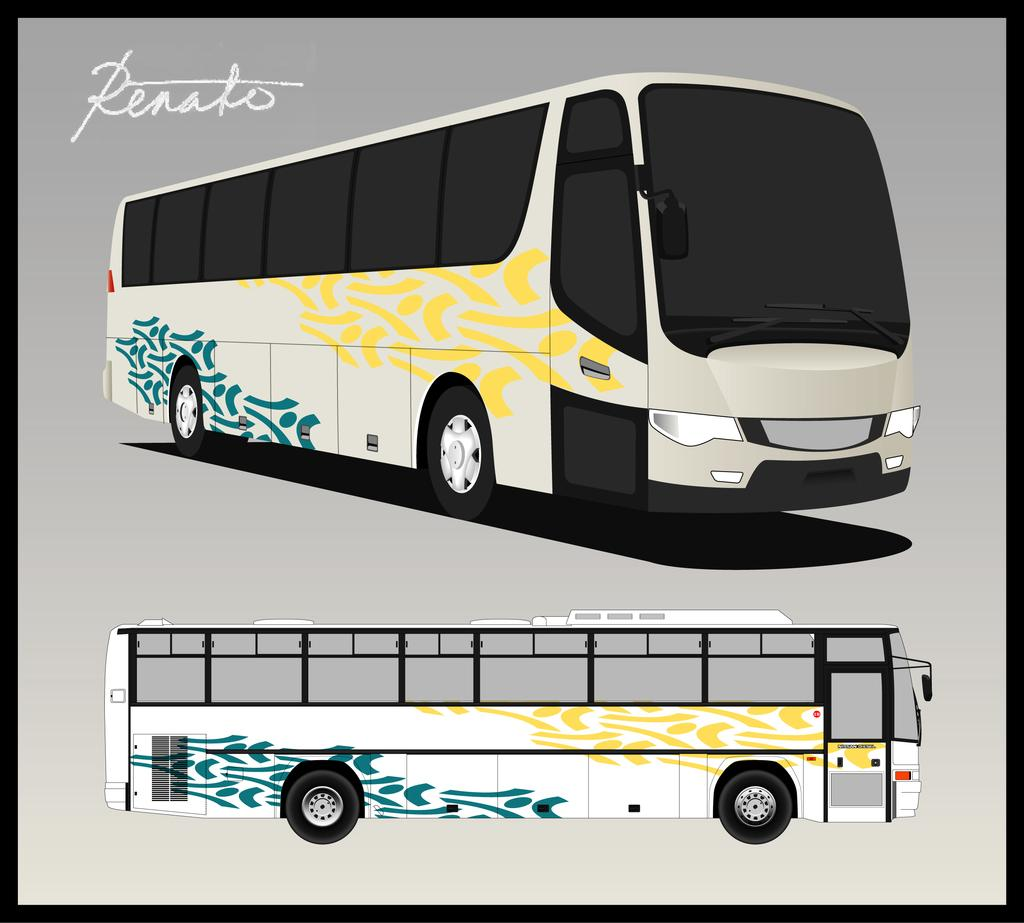<image>
Provide a brief description of the given image. A drawing of a white, Renato brand bus with yellow and gold accents. 